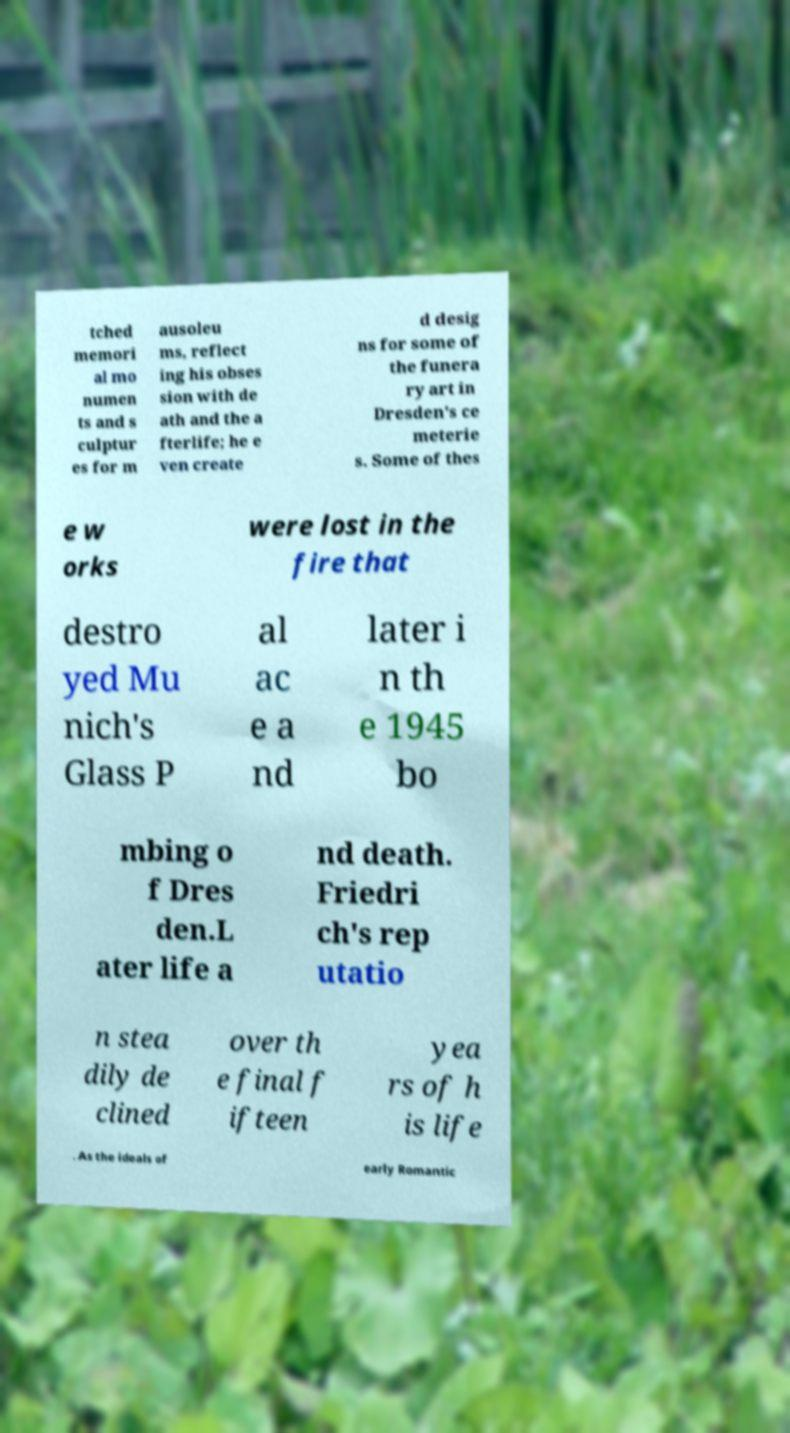What messages or text are displayed in this image? I need them in a readable, typed format. tched memori al mo numen ts and s culptur es for m ausoleu ms, reflect ing his obses sion with de ath and the a fterlife; he e ven create d desig ns for some of the funera ry art in Dresden's ce meterie s. Some of thes e w orks were lost in the fire that destro yed Mu nich's Glass P al ac e a nd later i n th e 1945 bo mbing o f Dres den.L ater life a nd death. Friedri ch's rep utatio n stea dily de clined over th e final f ifteen yea rs of h is life . As the ideals of early Romantic 